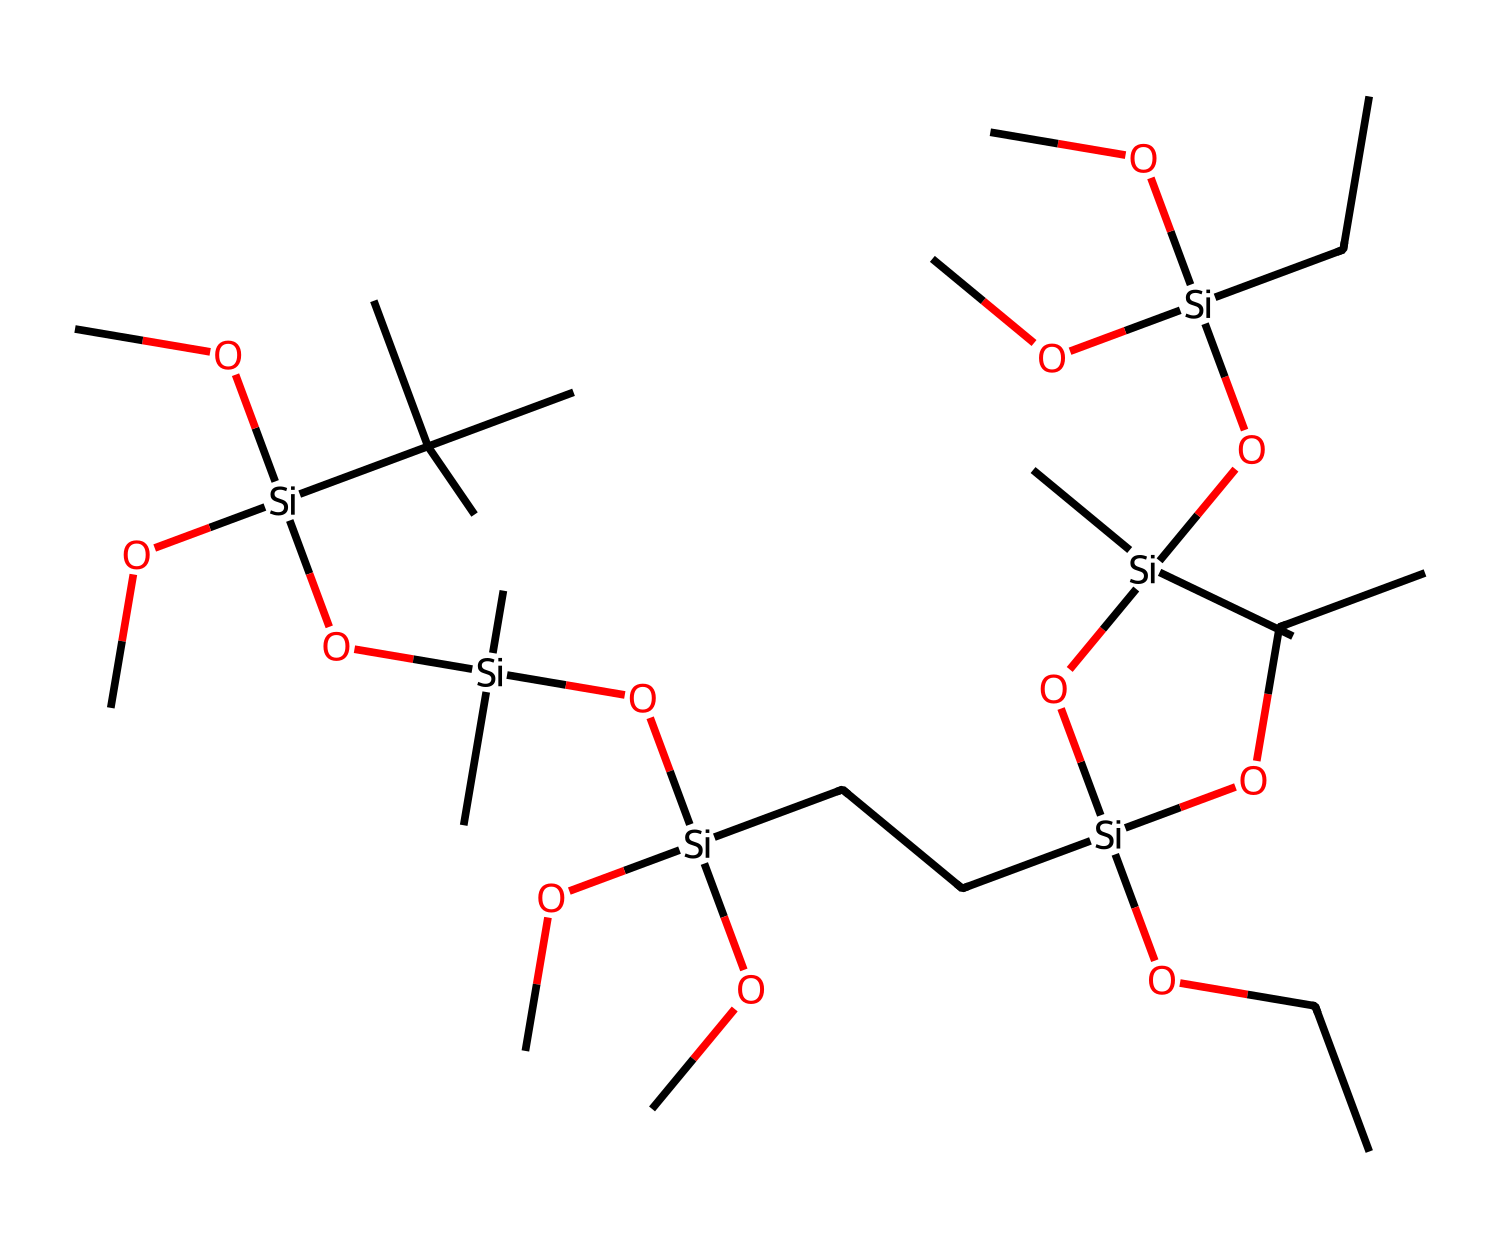What is the main backbone structure of this organosilicon compound? The chemical contains multiple silicon atoms linked together in a chain, which is typical for organosilicon compounds, especially in polymers. The repeating units of silicon in the structure represent the main backbone.
Answer: silicon backbone How many silicon atoms are present in this chemical structure? By examining the SMILES representation carefully, we can identify eleven silicon atoms denoted by the [Si] symbol within the structure.
Answer: eleven What type of functional groups are present in the chemical? The chemical contains multiple alkoxy groups (-OC) and hydroxyl groups (-OH), which are characteristic of organosilicon compounds that enhance their functionality in applications like protective coatings.
Answer: alkoxy and hydroxyl Which feature of this chemical contributes to its potential use in protective coatings? The presence of multiple hydroxyl (-OH) and alkoxy (-OC) groups enhances adhesion and cross-linking capabilities, which are crucial for protective coatings on stone surfaces.
Answer: hydroxyl and alkoxy groups What type of polymerization might be involved in forming this compound? The compound likely involves condensation polymerization, where the reaction between silanol groups (Si-OH) leads to the release of water, resulting in the formation of a siloxane network.
Answer: condensation polymerization 